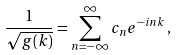<formula> <loc_0><loc_0><loc_500><loc_500>\frac { 1 } { \sqrt { g ( k ) } } = \sum _ { n = - \infty } ^ { \infty } c _ { n } e ^ { - i n k } \, ,</formula> 